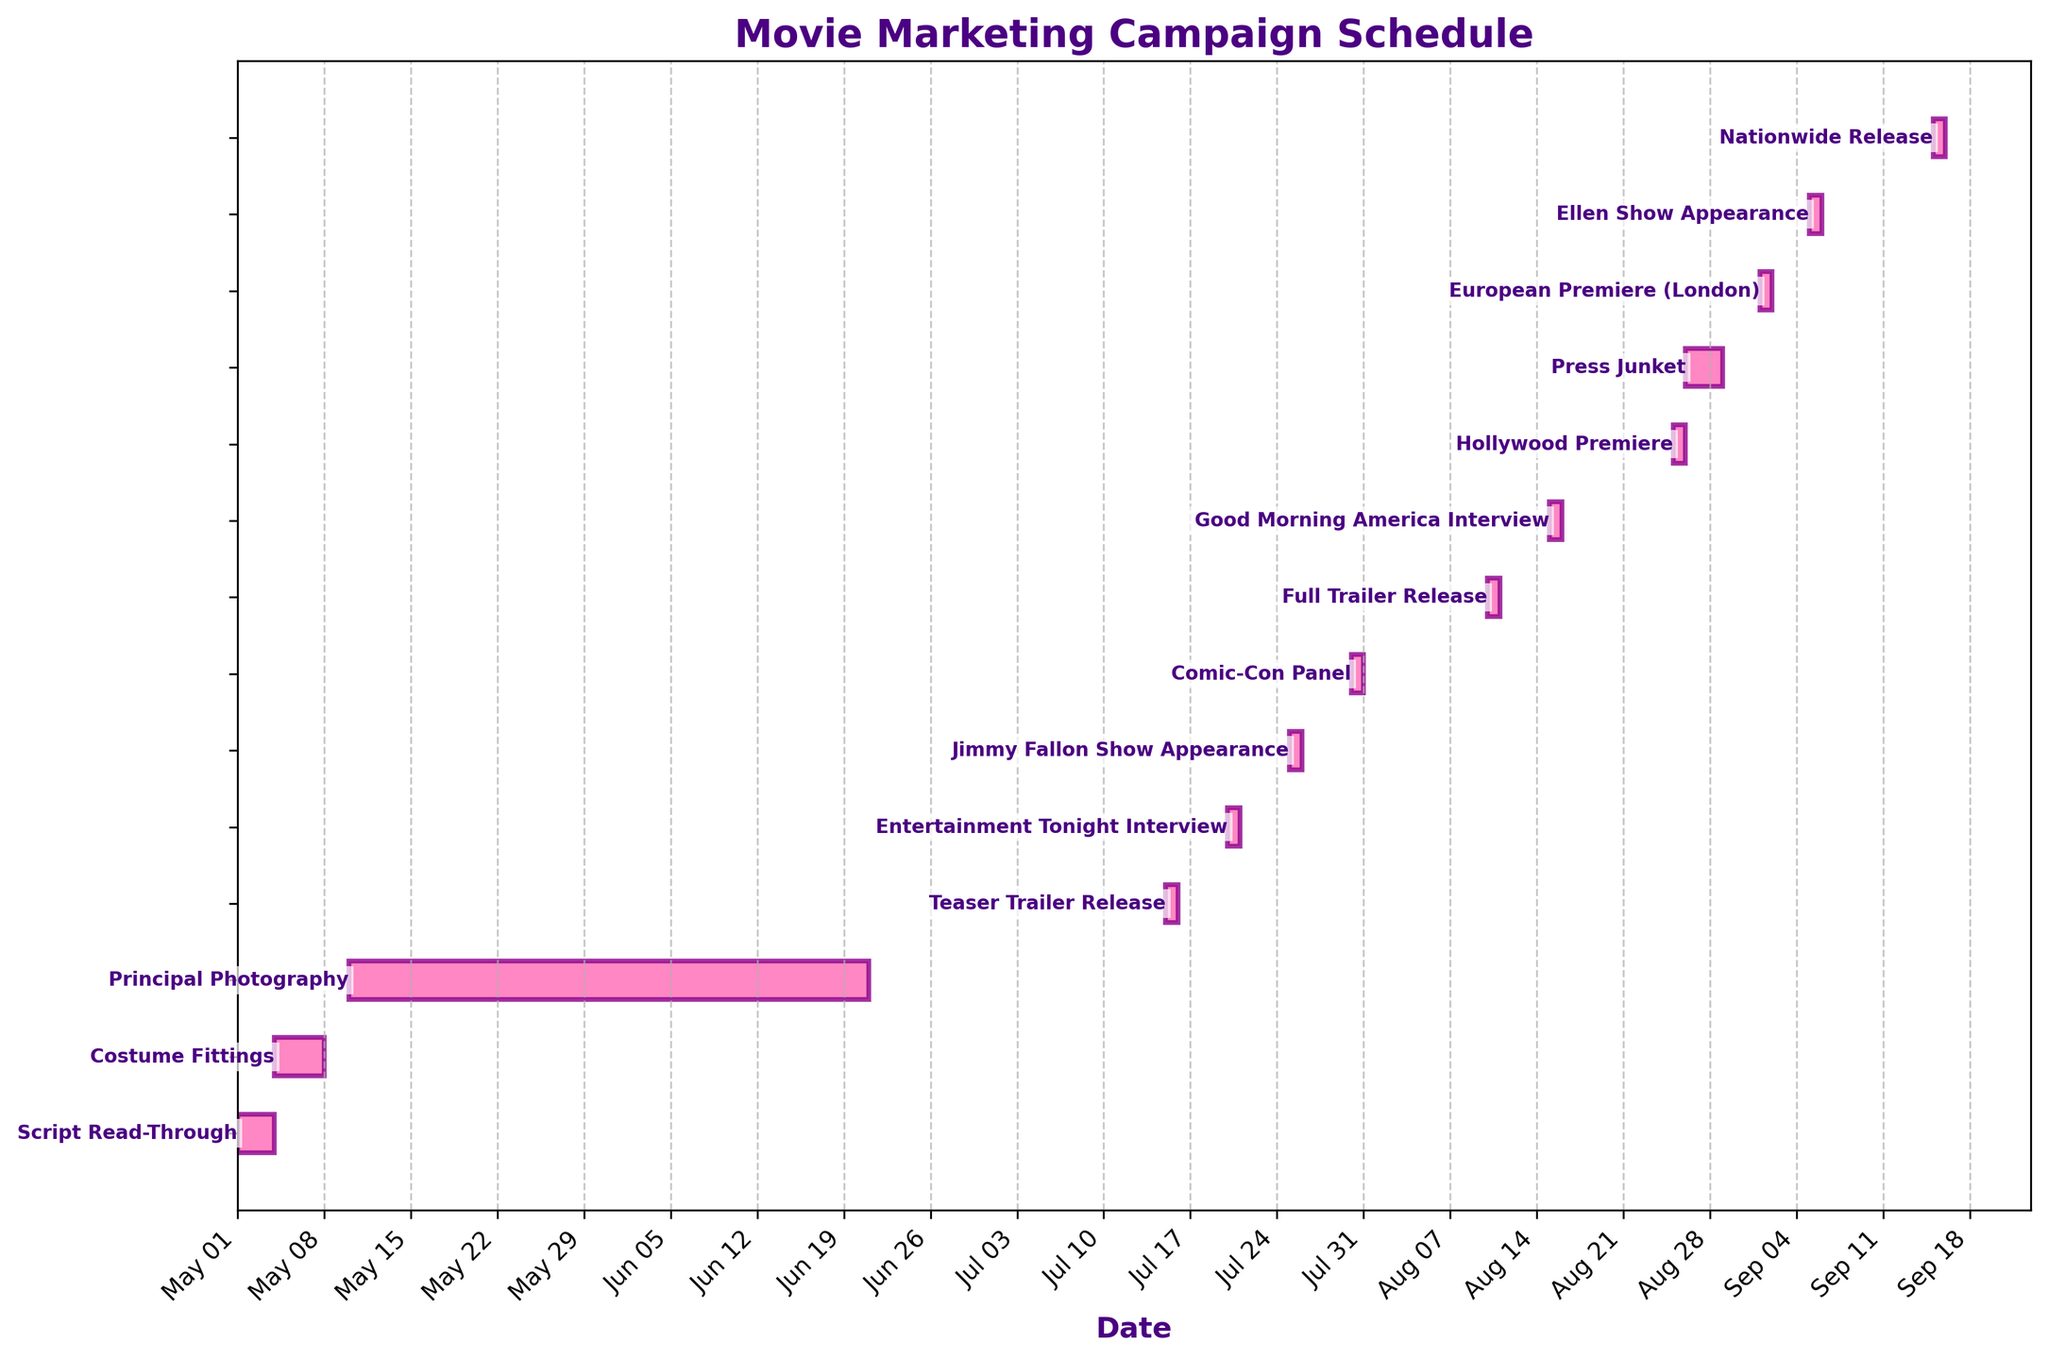When is the first marketing event scheduled? The first marketing event according to the Gantt Chart is the "Teaser Trailer Release," which is scheduled on July 15, 2023.
Answer: July 15, 2023 What is the title of the Gantt Chart? The title of the Gantt Chart is "Movie Marketing Campaign Schedule."
Answer: Movie Marketing Campaign Schedule Which event has the longest duration? By comparing the start and end dates across all tasks, "Principal Photography" spans the longest period from May 10, 2023, to June 20, 2023.
Answer: Principal Photography How many days does the "Costume Fittings" event span? The "Costume Fittings" event starts on May 4, 2023, and ends on May 7, 2023. This spans 4 days (May 4, 5, 6, and 7).
Answer: 4 days Which two events are scheduled on the same day in July? Both the "Entertainment Tonight Interview" and "Jimmy Fallon Show Appearance" are scheduled in July, but "Entertainment Tonight Interview" is on July 20, 2023, and "Jimmy Fallon Show Appearance" is on July 25, 2023. So, no events coincide.
Answer: None How many total events are there in August? According to the Gantt Chart, there are four events in August: the "Full Trailer Release" (Aug 10), "Good Morning America Interview" (Aug 15), "Hollywood Premiere" (Aug 25), and "Press Junket" (Aug 26-28).
Answer: 4 events Which event immediately precedes the "Nationwide Release"? The event before the "Nationwide Release" on September 15, 2023, is the "Ellen Show Appearance" scheduled for September 5, 2023.
Answer: Ellen Show Appearance What is the duration between the "European Premiere (London)" and the "Nationwide Release"? The "European Premiere (London)" is on September 1, 2023, and the "Nationwide Release" is on September 15, 2023. The duration between these two dates is 14 days.
Answer: 14 days What type of media appearances occur in July? In July, the media appearances include the "Entertainment Tonight Interview" on July 20 and the "Jimmy Fallon Show Appearance" on July 25.
Answer: Entertainment Tonight Interview, Jimmy Fallon Show Appearance 